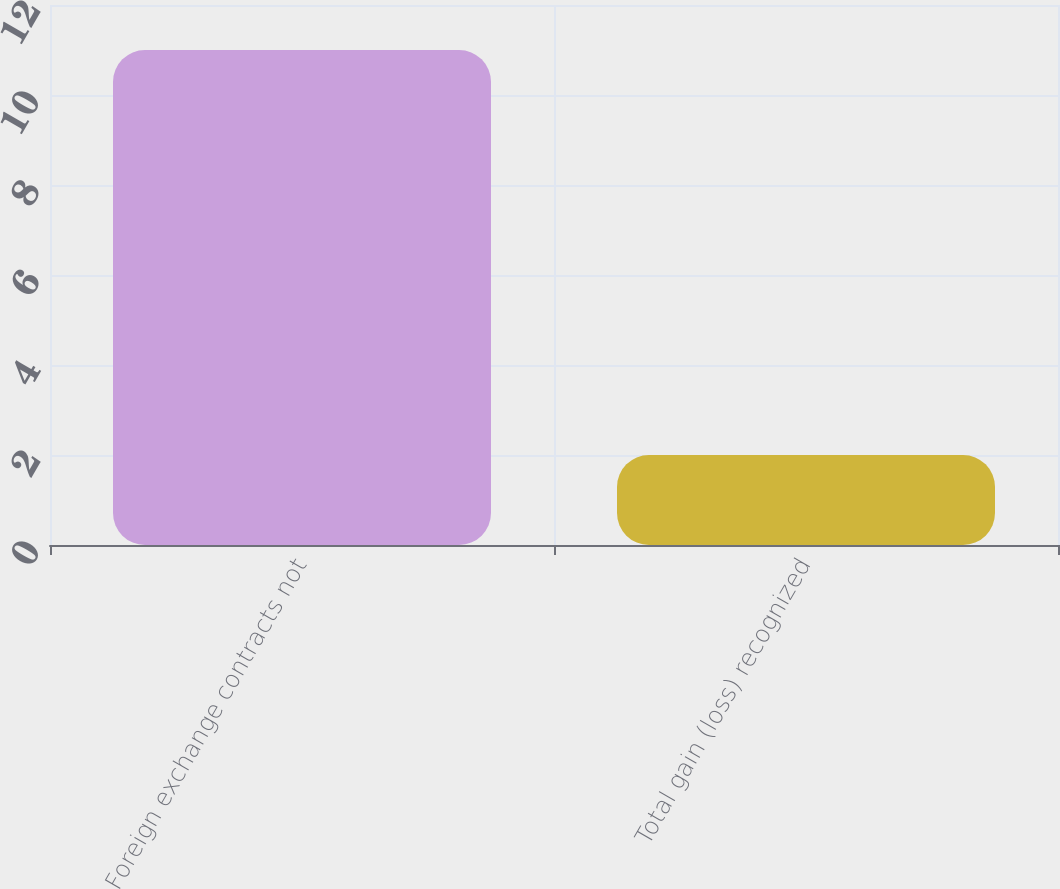<chart> <loc_0><loc_0><loc_500><loc_500><bar_chart><fcel>Foreign exchange contracts not<fcel>Total gain (loss) recognized<nl><fcel>11<fcel>2<nl></chart> 